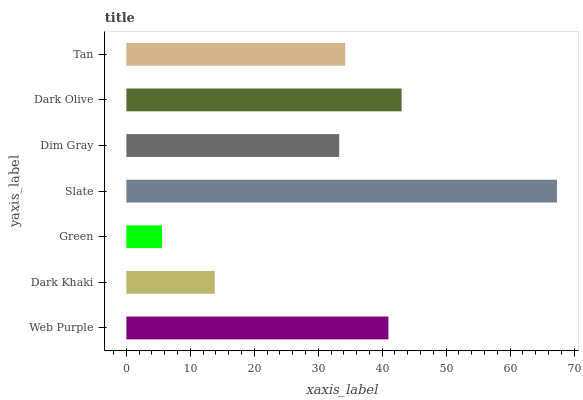Is Green the minimum?
Answer yes or no. Yes. Is Slate the maximum?
Answer yes or no. Yes. Is Dark Khaki the minimum?
Answer yes or no. No. Is Dark Khaki the maximum?
Answer yes or no. No. Is Web Purple greater than Dark Khaki?
Answer yes or no. Yes. Is Dark Khaki less than Web Purple?
Answer yes or no. Yes. Is Dark Khaki greater than Web Purple?
Answer yes or no. No. Is Web Purple less than Dark Khaki?
Answer yes or no. No. Is Tan the high median?
Answer yes or no. Yes. Is Tan the low median?
Answer yes or no. Yes. Is Slate the high median?
Answer yes or no. No. Is Dim Gray the low median?
Answer yes or no. No. 